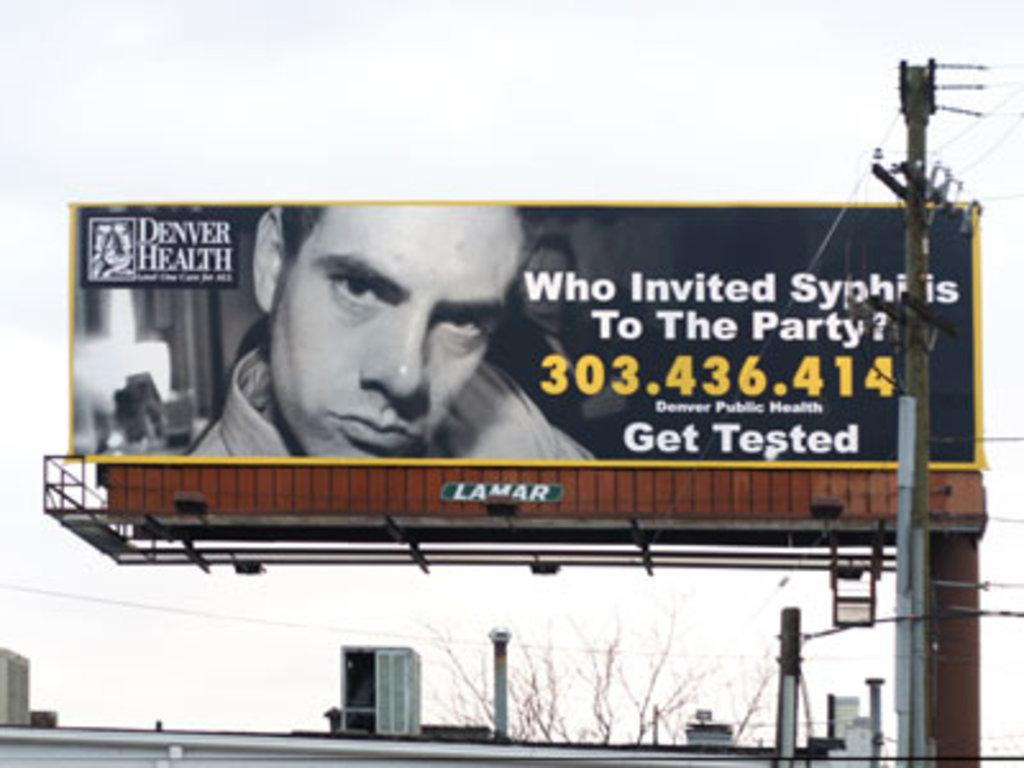<image>
Give a short and clear explanation of the subsequent image. A Denver Health billboard has a phone number on it. 